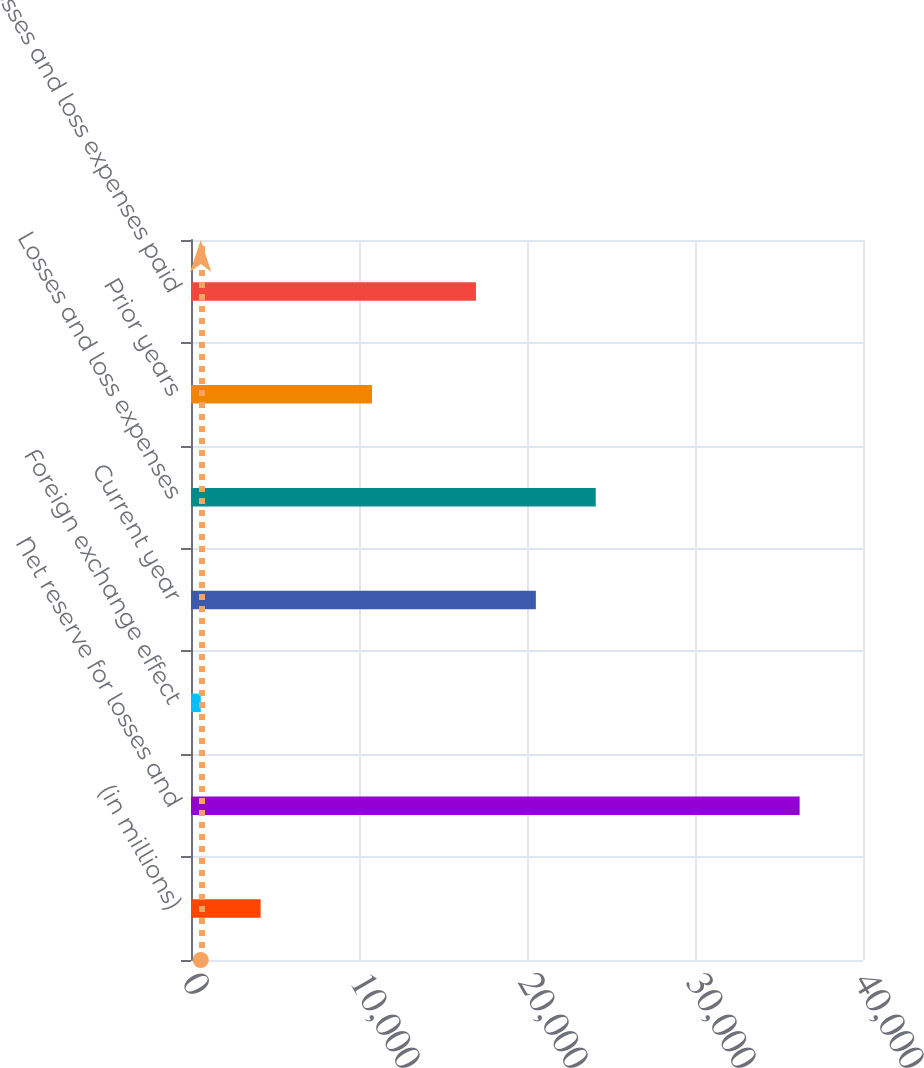Convert chart. <chart><loc_0><loc_0><loc_500><loc_500><bar_chart><fcel>(in millions)<fcel>Net reserve for losses and<fcel>Foreign exchange effect<fcel>Current year<fcel>Losses and loss expenses<fcel>Prior years<fcel>Losses and loss expenses paid<nl><fcel>4144.8<fcel>36228<fcel>580<fcel>20526.8<fcel>24091.6<fcel>10775<fcel>16962<nl></chart> 